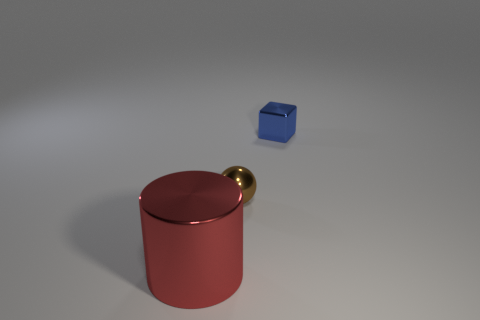Add 2 big cylinders. How many objects exist? 5 Subtract all cubes. How many objects are left? 2 Subtract 0 cyan cylinders. How many objects are left? 3 Subtract all small blue blocks. Subtract all blue blocks. How many objects are left? 1 Add 2 brown metal spheres. How many brown metal spheres are left? 3 Add 1 cyan cylinders. How many cyan cylinders exist? 1 